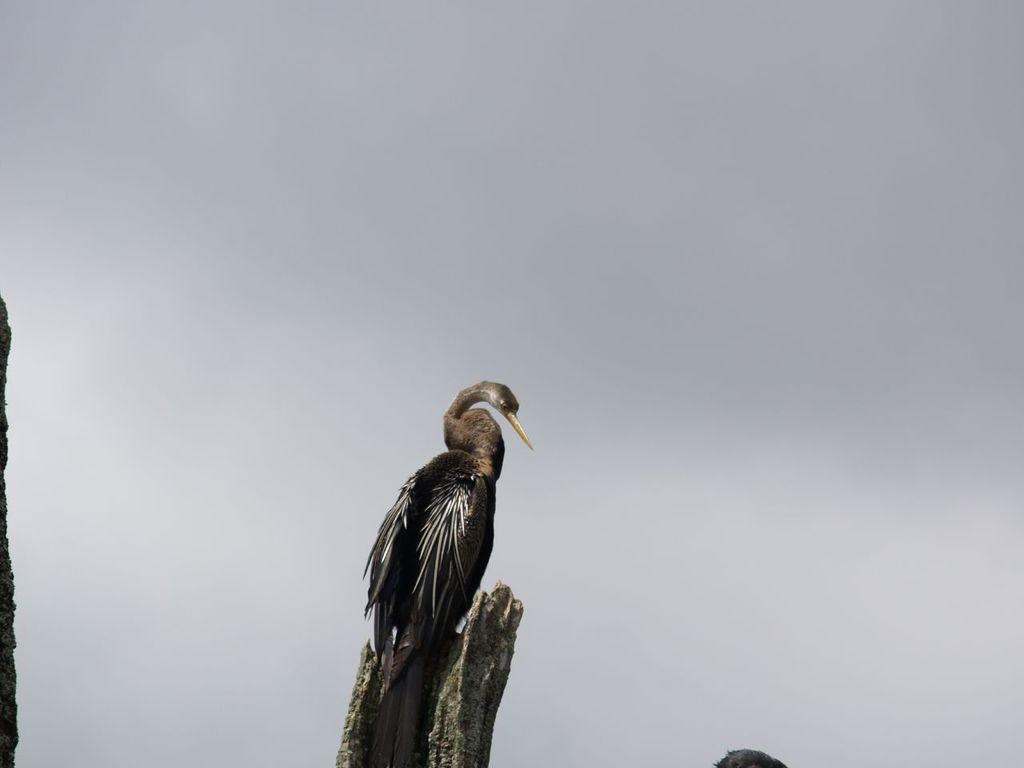What type of animal is in the image? There is a bird in the image. What color is the bird? The bird is black in color. What is located at the bottom of the image? There is a tree at the bottom of the image. What can be seen in the background of the image? The sky is visible in the background of the image. What type of paint is being used by the bird in the image? There is no paint or painting activity depicted in the image; it features a black bird and a tree. 